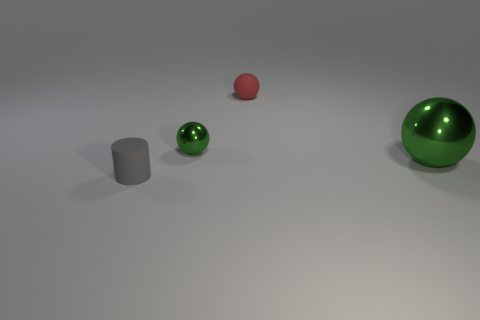Subtract all rubber spheres. How many spheres are left? 2 Subtract all green blocks. How many green balls are left? 2 Add 3 large brown matte things. How many objects exist? 7 Subtract all cylinders. How many objects are left? 3 Subtract all purple spheres. Subtract all blue cylinders. How many spheres are left? 3 Subtract all small red metal balls. Subtract all red matte balls. How many objects are left? 3 Add 4 green metal things. How many green metal things are left? 6 Add 1 big green metal objects. How many big green metal objects exist? 2 Subtract 0 blue cylinders. How many objects are left? 4 